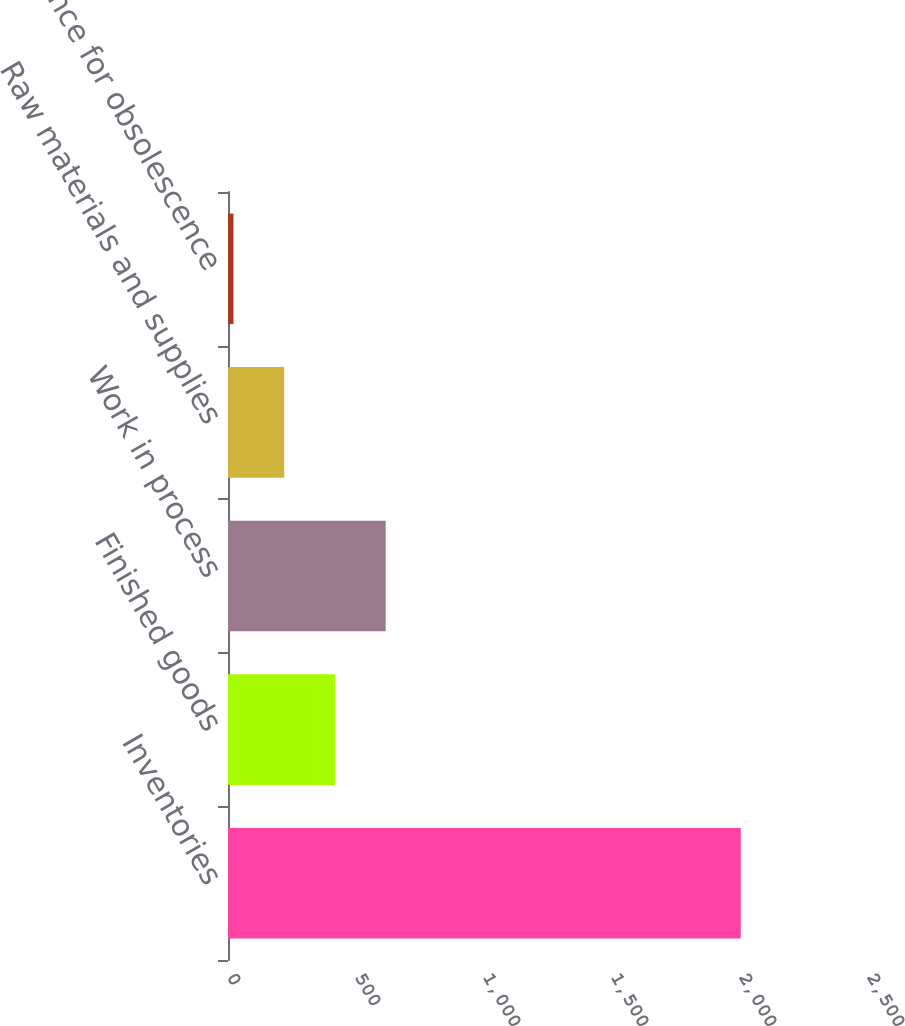Convert chart. <chart><loc_0><loc_0><loc_500><loc_500><bar_chart><fcel>Inventories<fcel>Finished goods<fcel>Work in process<fcel>Raw materials and supplies<fcel>Allowance for obsolescence<nl><fcel>2003<fcel>417.72<fcel>615.88<fcel>219.56<fcel>21.4<nl></chart> 